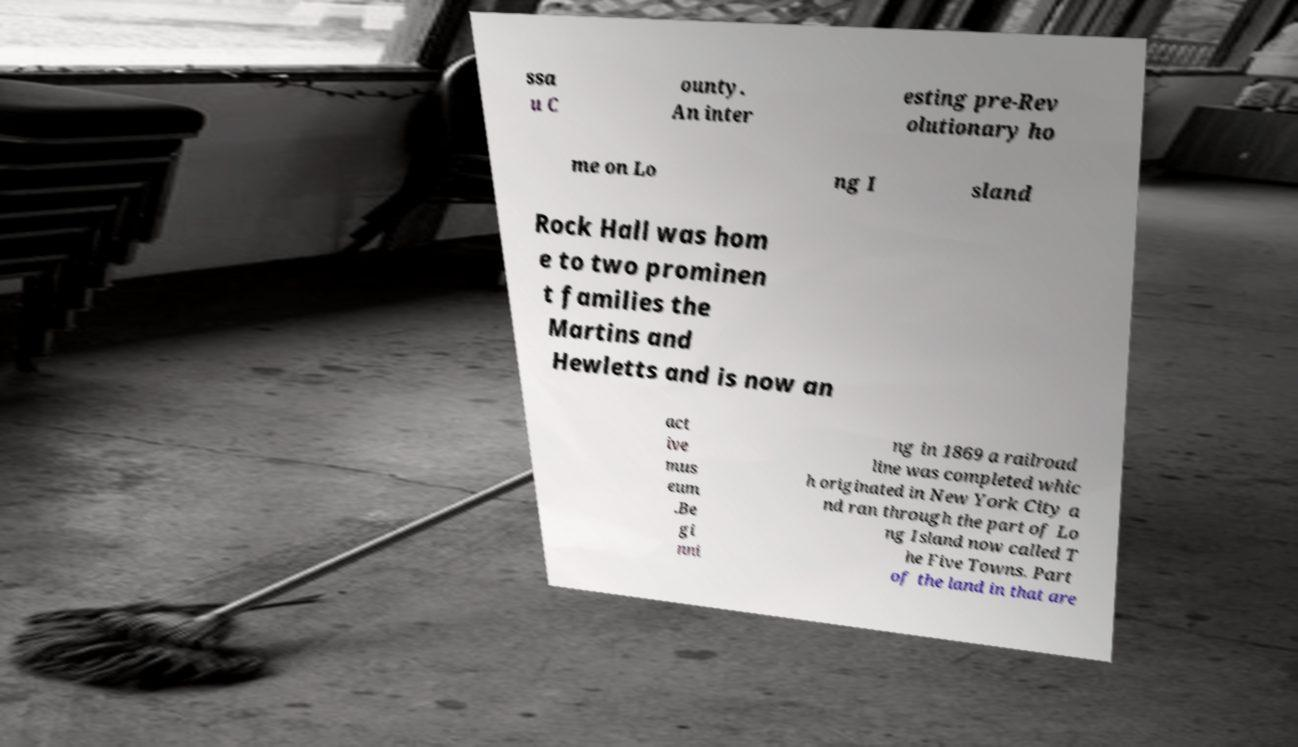Please read and relay the text visible in this image. What does it say? ssa u C ounty. An inter esting pre-Rev olutionary ho me on Lo ng I sland Rock Hall was hom e to two prominen t families the Martins and Hewletts and is now an act ive mus eum .Be gi nni ng in 1869 a railroad line was completed whic h originated in New York City a nd ran through the part of Lo ng Island now called T he Five Towns. Part of the land in that are 